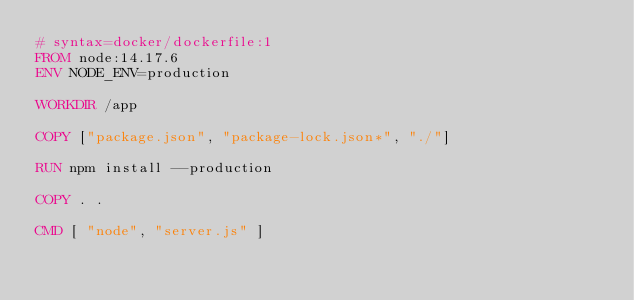Convert code to text. <code><loc_0><loc_0><loc_500><loc_500><_Dockerfile_># syntax=docker/dockerfile:1
FROM node:14.17.6
ENV NODE_ENV=production

WORKDIR /app

COPY ["package.json", "package-lock.json*", "./"]

RUN npm install --production

COPY . .

CMD [ "node", "server.js" ]</code> 